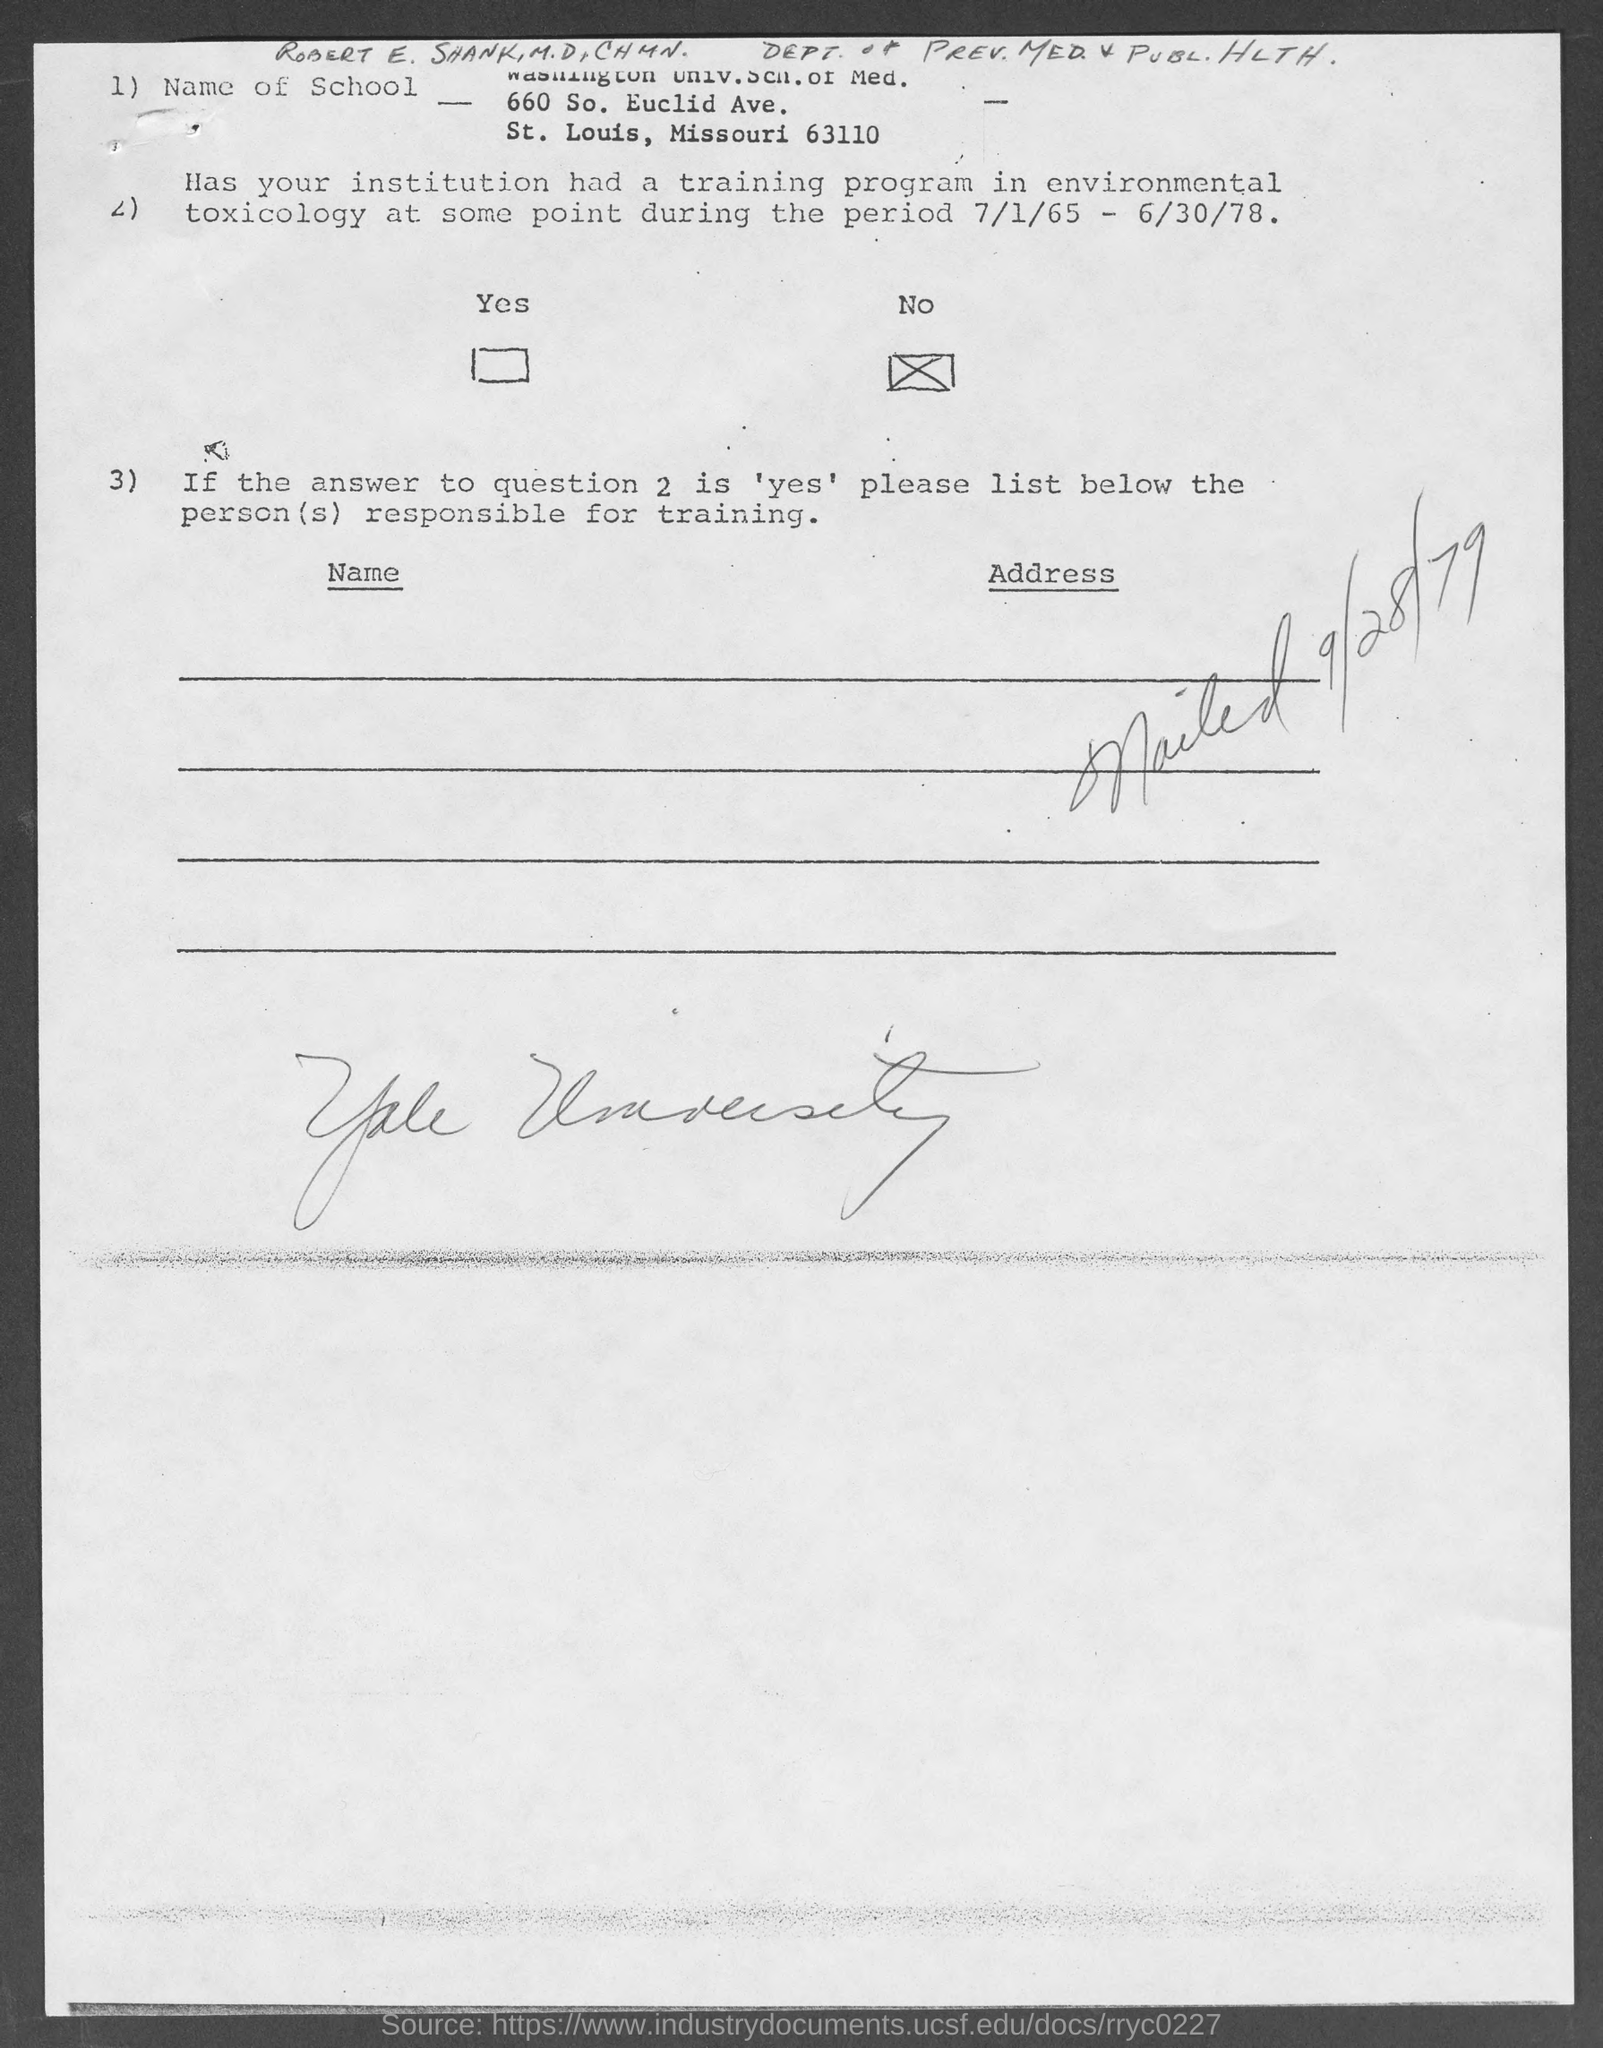Identify some key points in this picture. The mailing took place on September 28, 1979. 